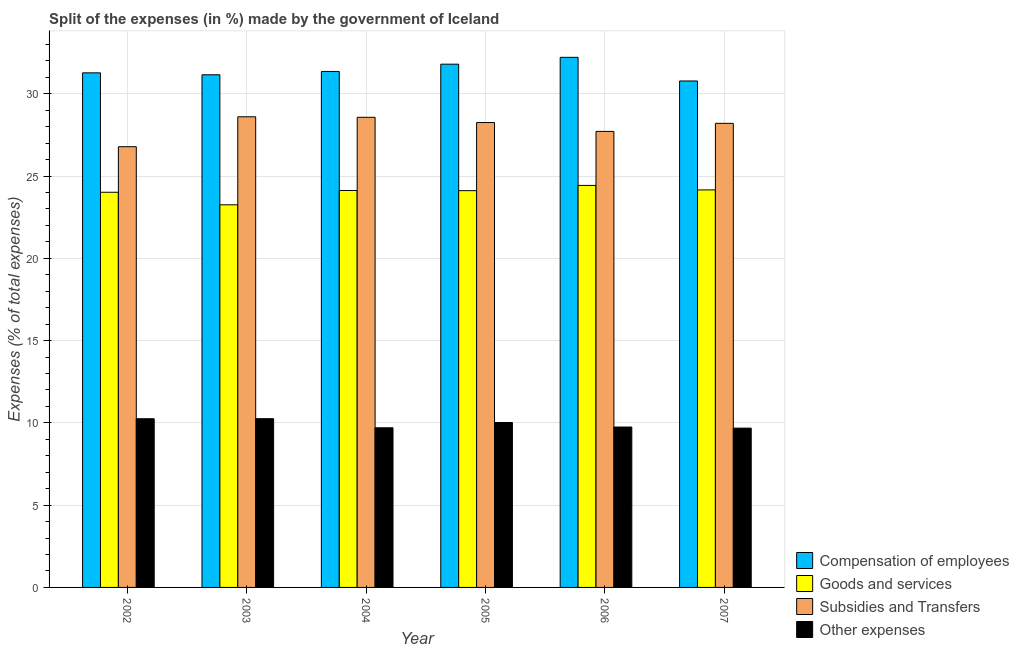How many different coloured bars are there?
Keep it short and to the point. 4. How many groups of bars are there?
Keep it short and to the point. 6. What is the label of the 3rd group of bars from the left?
Give a very brief answer. 2004. In how many cases, is the number of bars for a given year not equal to the number of legend labels?
Offer a very short reply. 0. What is the percentage of amount spent on goods and services in 2002?
Provide a short and direct response. 24.01. Across all years, what is the maximum percentage of amount spent on subsidies?
Your answer should be compact. 28.6. Across all years, what is the minimum percentage of amount spent on goods and services?
Give a very brief answer. 23.25. In which year was the percentage of amount spent on compensation of employees minimum?
Your response must be concise. 2007. What is the total percentage of amount spent on other expenses in the graph?
Provide a short and direct response. 59.66. What is the difference between the percentage of amount spent on subsidies in 2002 and that in 2004?
Provide a succinct answer. -1.79. What is the difference between the percentage of amount spent on goods and services in 2005 and the percentage of amount spent on other expenses in 2007?
Provide a short and direct response. -0.04. What is the average percentage of amount spent on compensation of employees per year?
Give a very brief answer. 31.43. In how many years, is the percentage of amount spent on other expenses greater than 32 %?
Provide a short and direct response. 0. What is the ratio of the percentage of amount spent on compensation of employees in 2004 to that in 2007?
Your answer should be compact. 1.02. Is the percentage of amount spent on compensation of employees in 2004 less than that in 2005?
Offer a terse response. Yes. Is the difference between the percentage of amount spent on other expenses in 2002 and 2004 greater than the difference between the percentage of amount spent on goods and services in 2002 and 2004?
Your answer should be very brief. No. What is the difference between the highest and the second highest percentage of amount spent on other expenses?
Your answer should be compact. 0. What is the difference between the highest and the lowest percentage of amount spent on other expenses?
Offer a terse response. 0.57. In how many years, is the percentage of amount spent on goods and services greater than the average percentage of amount spent on goods and services taken over all years?
Your response must be concise. 5. Is it the case that in every year, the sum of the percentage of amount spent on goods and services and percentage of amount spent on compensation of employees is greater than the sum of percentage of amount spent on other expenses and percentage of amount spent on subsidies?
Keep it short and to the point. Yes. What does the 3rd bar from the left in 2006 represents?
Provide a succinct answer. Subsidies and Transfers. What does the 2nd bar from the right in 2007 represents?
Make the answer very short. Subsidies and Transfers. Is it the case that in every year, the sum of the percentage of amount spent on compensation of employees and percentage of amount spent on goods and services is greater than the percentage of amount spent on subsidies?
Give a very brief answer. Yes. Are all the bars in the graph horizontal?
Offer a terse response. No. What is the difference between two consecutive major ticks on the Y-axis?
Your response must be concise. 5. Does the graph contain any zero values?
Provide a succinct answer. No. Does the graph contain grids?
Make the answer very short. Yes. Where does the legend appear in the graph?
Offer a terse response. Bottom right. How many legend labels are there?
Offer a terse response. 4. What is the title of the graph?
Offer a terse response. Split of the expenses (in %) made by the government of Iceland. What is the label or title of the Y-axis?
Offer a very short reply. Expenses (% of total expenses). What is the Expenses (% of total expenses) of Compensation of employees in 2002?
Your answer should be very brief. 31.27. What is the Expenses (% of total expenses) in Goods and services in 2002?
Make the answer very short. 24.01. What is the Expenses (% of total expenses) of Subsidies and Transfers in 2002?
Offer a terse response. 26.78. What is the Expenses (% of total expenses) of Other expenses in 2002?
Make the answer very short. 10.25. What is the Expenses (% of total expenses) in Compensation of employees in 2003?
Your answer should be compact. 31.15. What is the Expenses (% of total expenses) of Goods and services in 2003?
Provide a short and direct response. 23.25. What is the Expenses (% of total expenses) of Subsidies and Transfers in 2003?
Your answer should be very brief. 28.6. What is the Expenses (% of total expenses) in Other expenses in 2003?
Ensure brevity in your answer.  10.26. What is the Expenses (% of total expenses) in Compensation of employees in 2004?
Keep it short and to the point. 31.36. What is the Expenses (% of total expenses) of Goods and services in 2004?
Offer a very short reply. 24.12. What is the Expenses (% of total expenses) of Subsidies and Transfers in 2004?
Provide a short and direct response. 28.57. What is the Expenses (% of total expenses) of Other expenses in 2004?
Provide a succinct answer. 9.7. What is the Expenses (% of total expenses) in Compensation of employees in 2005?
Offer a terse response. 31.8. What is the Expenses (% of total expenses) of Goods and services in 2005?
Keep it short and to the point. 24.11. What is the Expenses (% of total expenses) in Subsidies and Transfers in 2005?
Your answer should be compact. 28.25. What is the Expenses (% of total expenses) in Other expenses in 2005?
Ensure brevity in your answer.  10.02. What is the Expenses (% of total expenses) of Compensation of employees in 2006?
Make the answer very short. 32.21. What is the Expenses (% of total expenses) of Goods and services in 2006?
Provide a short and direct response. 24.43. What is the Expenses (% of total expenses) of Subsidies and Transfers in 2006?
Your response must be concise. 27.71. What is the Expenses (% of total expenses) of Other expenses in 2006?
Make the answer very short. 9.75. What is the Expenses (% of total expenses) of Compensation of employees in 2007?
Keep it short and to the point. 30.78. What is the Expenses (% of total expenses) in Goods and services in 2007?
Make the answer very short. 24.16. What is the Expenses (% of total expenses) in Subsidies and Transfers in 2007?
Your answer should be compact. 28.2. What is the Expenses (% of total expenses) in Other expenses in 2007?
Provide a short and direct response. 9.68. Across all years, what is the maximum Expenses (% of total expenses) of Compensation of employees?
Offer a very short reply. 32.21. Across all years, what is the maximum Expenses (% of total expenses) of Goods and services?
Your response must be concise. 24.43. Across all years, what is the maximum Expenses (% of total expenses) of Subsidies and Transfers?
Offer a very short reply. 28.6. Across all years, what is the maximum Expenses (% of total expenses) of Other expenses?
Provide a succinct answer. 10.26. Across all years, what is the minimum Expenses (% of total expenses) in Compensation of employees?
Your response must be concise. 30.78. Across all years, what is the minimum Expenses (% of total expenses) in Goods and services?
Offer a very short reply. 23.25. Across all years, what is the minimum Expenses (% of total expenses) of Subsidies and Transfers?
Provide a succinct answer. 26.78. Across all years, what is the minimum Expenses (% of total expenses) of Other expenses?
Ensure brevity in your answer.  9.68. What is the total Expenses (% of total expenses) in Compensation of employees in the graph?
Give a very brief answer. 188.57. What is the total Expenses (% of total expenses) in Goods and services in the graph?
Keep it short and to the point. 144.09. What is the total Expenses (% of total expenses) of Subsidies and Transfers in the graph?
Make the answer very short. 168.12. What is the total Expenses (% of total expenses) of Other expenses in the graph?
Your answer should be compact. 59.66. What is the difference between the Expenses (% of total expenses) in Compensation of employees in 2002 and that in 2003?
Provide a succinct answer. 0.12. What is the difference between the Expenses (% of total expenses) of Goods and services in 2002 and that in 2003?
Keep it short and to the point. 0.76. What is the difference between the Expenses (% of total expenses) in Subsidies and Transfers in 2002 and that in 2003?
Provide a succinct answer. -1.82. What is the difference between the Expenses (% of total expenses) of Other expenses in 2002 and that in 2003?
Ensure brevity in your answer.  -0. What is the difference between the Expenses (% of total expenses) of Compensation of employees in 2002 and that in 2004?
Give a very brief answer. -0.09. What is the difference between the Expenses (% of total expenses) in Goods and services in 2002 and that in 2004?
Provide a short and direct response. -0.11. What is the difference between the Expenses (% of total expenses) in Subsidies and Transfers in 2002 and that in 2004?
Give a very brief answer. -1.79. What is the difference between the Expenses (% of total expenses) in Other expenses in 2002 and that in 2004?
Keep it short and to the point. 0.55. What is the difference between the Expenses (% of total expenses) in Compensation of employees in 2002 and that in 2005?
Your answer should be compact. -0.53. What is the difference between the Expenses (% of total expenses) of Goods and services in 2002 and that in 2005?
Keep it short and to the point. -0.1. What is the difference between the Expenses (% of total expenses) in Subsidies and Transfers in 2002 and that in 2005?
Make the answer very short. -1.47. What is the difference between the Expenses (% of total expenses) of Other expenses in 2002 and that in 2005?
Offer a very short reply. 0.23. What is the difference between the Expenses (% of total expenses) in Compensation of employees in 2002 and that in 2006?
Provide a short and direct response. -0.94. What is the difference between the Expenses (% of total expenses) in Goods and services in 2002 and that in 2006?
Keep it short and to the point. -0.42. What is the difference between the Expenses (% of total expenses) of Subsidies and Transfers in 2002 and that in 2006?
Keep it short and to the point. -0.93. What is the difference between the Expenses (% of total expenses) in Other expenses in 2002 and that in 2006?
Keep it short and to the point. 0.5. What is the difference between the Expenses (% of total expenses) in Compensation of employees in 2002 and that in 2007?
Make the answer very short. 0.49. What is the difference between the Expenses (% of total expenses) in Goods and services in 2002 and that in 2007?
Provide a succinct answer. -0.14. What is the difference between the Expenses (% of total expenses) in Subsidies and Transfers in 2002 and that in 2007?
Ensure brevity in your answer.  -1.42. What is the difference between the Expenses (% of total expenses) in Other expenses in 2002 and that in 2007?
Offer a terse response. 0.57. What is the difference between the Expenses (% of total expenses) in Compensation of employees in 2003 and that in 2004?
Your answer should be compact. -0.2. What is the difference between the Expenses (% of total expenses) in Goods and services in 2003 and that in 2004?
Provide a short and direct response. -0.87. What is the difference between the Expenses (% of total expenses) in Subsidies and Transfers in 2003 and that in 2004?
Make the answer very short. 0.03. What is the difference between the Expenses (% of total expenses) in Other expenses in 2003 and that in 2004?
Keep it short and to the point. 0.55. What is the difference between the Expenses (% of total expenses) in Compensation of employees in 2003 and that in 2005?
Keep it short and to the point. -0.65. What is the difference between the Expenses (% of total expenses) in Goods and services in 2003 and that in 2005?
Your answer should be very brief. -0.86. What is the difference between the Expenses (% of total expenses) in Subsidies and Transfers in 2003 and that in 2005?
Your answer should be very brief. 0.35. What is the difference between the Expenses (% of total expenses) in Other expenses in 2003 and that in 2005?
Give a very brief answer. 0.23. What is the difference between the Expenses (% of total expenses) of Compensation of employees in 2003 and that in 2006?
Keep it short and to the point. -1.06. What is the difference between the Expenses (% of total expenses) of Goods and services in 2003 and that in 2006?
Keep it short and to the point. -1.18. What is the difference between the Expenses (% of total expenses) of Subsidies and Transfers in 2003 and that in 2006?
Ensure brevity in your answer.  0.89. What is the difference between the Expenses (% of total expenses) in Other expenses in 2003 and that in 2006?
Keep it short and to the point. 0.51. What is the difference between the Expenses (% of total expenses) in Compensation of employees in 2003 and that in 2007?
Offer a very short reply. 0.38. What is the difference between the Expenses (% of total expenses) of Goods and services in 2003 and that in 2007?
Your answer should be very brief. -0.91. What is the difference between the Expenses (% of total expenses) of Subsidies and Transfers in 2003 and that in 2007?
Your answer should be very brief. 0.4. What is the difference between the Expenses (% of total expenses) in Other expenses in 2003 and that in 2007?
Offer a very short reply. 0.57. What is the difference between the Expenses (% of total expenses) in Compensation of employees in 2004 and that in 2005?
Your response must be concise. -0.44. What is the difference between the Expenses (% of total expenses) of Goods and services in 2004 and that in 2005?
Ensure brevity in your answer.  0.01. What is the difference between the Expenses (% of total expenses) in Subsidies and Transfers in 2004 and that in 2005?
Provide a succinct answer. 0.32. What is the difference between the Expenses (% of total expenses) in Other expenses in 2004 and that in 2005?
Offer a very short reply. -0.32. What is the difference between the Expenses (% of total expenses) in Compensation of employees in 2004 and that in 2006?
Offer a very short reply. -0.86. What is the difference between the Expenses (% of total expenses) of Goods and services in 2004 and that in 2006?
Offer a terse response. -0.31. What is the difference between the Expenses (% of total expenses) in Subsidies and Transfers in 2004 and that in 2006?
Make the answer very short. 0.86. What is the difference between the Expenses (% of total expenses) in Other expenses in 2004 and that in 2006?
Your answer should be very brief. -0.05. What is the difference between the Expenses (% of total expenses) of Compensation of employees in 2004 and that in 2007?
Your answer should be compact. 0.58. What is the difference between the Expenses (% of total expenses) of Goods and services in 2004 and that in 2007?
Your answer should be very brief. -0.03. What is the difference between the Expenses (% of total expenses) of Subsidies and Transfers in 2004 and that in 2007?
Your answer should be compact. 0.37. What is the difference between the Expenses (% of total expenses) of Other expenses in 2004 and that in 2007?
Your answer should be compact. 0.02. What is the difference between the Expenses (% of total expenses) in Compensation of employees in 2005 and that in 2006?
Keep it short and to the point. -0.42. What is the difference between the Expenses (% of total expenses) of Goods and services in 2005 and that in 2006?
Your response must be concise. -0.32. What is the difference between the Expenses (% of total expenses) of Subsidies and Transfers in 2005 and that in 2006?
Your response must be concise. 0.54. What is the difference between the Expenses (% of total expenses) in Other expenses in 2005 and that in 2006?
Keep it short and to the point. 0.28. What is the difference between the Expenses (% of total expenses) of Compensation of employees in 2005 and that in 2007?
Your answer should be very brief. 1.02. What is the difference between the Expenses (% of total expenses) of Goods and services in 2005 and that in 2007?
Ensure brevity in your answer.  -0.04. What is the difference between the Expenses (% of total expenses) in Subsidies and Transfers in 2005 and that in 2007?
Make the answer very short. 0.05. What is the difference between the Expenses (% of total expenses) of Other expenses in 2005 and that in 2007?
Make the answer very short. 0.34. What is the difference between the Expenses (% of total expenses) in Compensation of employees in 2006 and that in 2007?
Your response must be concise. 1.44. What is the difference between the Expenses (% of total expenses) of Goods and services in 2006 and that in 2007?
Provide a short and direct response. 0.27. What is the difference between the Expenses (% of total expenses) in Subsidies and Transfers in 2006 and that in 2007?
Your answer should be very brief. -0.49. What is the difference between the Expenses (% of total expenses) of Other expenses in 2006 and that in 2007?
Keep it short and to the point. 0.07. What is the difference between the Expenses (% of total expenses) in Compensation of employees in 2002 and the Expenses (% of total expenses) in Goods and services in 2003?
Provide a short and direct response. 8.02. What is the difference between the Expenses (% of total expenses) in Compensation of employees in 2002 and the Expenses (% of total expenses) in Subsidies and Transfers in 2003?
Give a very brief answer. 2.67. What is the difference between the Expenses (% of total expenses) of Compensation of employees in 2002 and the Expenses (% of total expenses) of Other expenses in 2003?
Ensure brevity in your answer.  21.02. What is the difference between the Expenses (% of total expenses) of Goods and services in 2002 and the Expenses (% of total expenses) of Subsidies and Transfers in 2003?
Ensure brevity in your answer.  -4.59. What is the difference between the Expenses (% of total expenses) in Goods and services in 2002 and the Expenses (% of total expenses) in Other expenses in 2003?
Provide a short and direct response. 13.76. What is the difference between the Expenses (% of total expenses) in Subsidies and Transfers in 2002 and the Expenses (% of total expenses) in Other expenses in 2003?
Provide a succinct answer. 16.53. What is the difference between the Expenses (% of total expenses) in Compensation of employees in 2002 and the Expenses (% of total expenses) in Goods and services in 2004?
Give a very brief answer. 7.15. What is the difference between the Expenses (% of total expenses) of Compensation of employees in 2002 and the Expenses (% of total expenses) of Subsidies and Transfers in 2004?
Your answer should be very brief. 2.7. What is the difference between the Expenses (% of total expenses) in Compensation of employees in 2002 and the Expenses (% of total expenses) in Other expenses in 2004?
Offer a very short reply. 21.57. What is the difference between the Expenses (% of total expenses) in Goods and services in 2002 and the Expenses (% of total expenses) in Subsidies and Transfers in 2004?
Give a very brief answer. -4.55. What is the difference between the Expenses (% of total expenses) in Goods and services in 2002 and the Expenses (% of total expenses) in Other expenses in 2004?
Make the answer very short. 14.31. What is the difference between the Expenses (% of total expenses) of Subsidies and Transfers in 2002 and the Expenses (% of total expenses) of Other expenses in 2004?
Keep it short and to the point. 17.08. What is the difference between the Expenses (% of total expenses) in Compensation of employees in 2002 and the Expenses (% of total expenses) in Goods and services in 2005?
Your answer should be very brief. 7.16. What is the difference between the Expenses (% of total expenses) in Compensation of employees in 2002 and the Expenses (% of total expenses) in Subsidies and Transfers in 2005?
Give a very brief answer. 3.02. What is the difference between the Expenses (% of total expenses) of Compensation of employees in 2002 and the Expenses (% of total expenses) of Other expenses in 2005?
Provide a short and direct response. 21.25. What is the difference between the Expenses (% of total expenses) in Goods and services in 2002 and the Expenses (% of total expenses) in Subsidies and Transfers in 2005?
Offer a terse response. -4.24. What is the difference between the Expenses (% of total expenses) in Goods and services in 2002 and the Expenses (% of total expenses) in Other expenses in 2005?
Your answer should be compact. 13.99. What is the difference between the Expenses (% of total expenses) of Subsidies and Transfers in 2002 and the Expenses (% of total expenses) of Other expenses in 2005?
Offer a very short reply. 16.76. What is the difference between the Expenses (% of total expenses) of Compensation of employees in 2002 and the Expenses (% of total expenses) of Goods and services in 2006?
Provide a succinct answer. 6.84. What is the difference between the Expenses (% of total expenses) in Compensation of employees in 2002 and the Expenses (% of total expenses) in Subsidies and Transfers in 2006?
Give a very brief answer. 3.56. What is the difference between the Expenses (% of total expenses) of Compensation of employees in 2002 and the Expenses (% of total expenses) of Other expenses in 2006?
Your answer should be very brief. 21.52. What is the difference between the Expenses (% of total expenses) in Goods and services in 2002 and the Expenses (% of total expenses) in Subsidies and Transfers in 2006?
Offer a terse response. -3.7. What is the difference between the Expenses (% of total expenses) in Goods and services in 2002 and the Expenses (% of total expenses) in Other expenses in 2006?
Your answer should be very brief. 14.27. What is the difference between the Expenses (% of total expenses) in Subsidies and Transfers in 2002 and the Expenses (% of total expenses) in Other expenses in 2006?
Offer a terse response. 17.04. What is the difference between the Expenses (% of total expenses) in Compensation of employees in 2002 and the Expenses (% of total expenses) in Goods and services in 2007?
Make the answer very short. 7.11. What is the difference between the Expenses (% of total expenses) of Compensation of employees in 2002 and the Expenses (% of total expenses) of Subsidies and Transfers in 2007?
Ensure brevity in your answer.  3.07. What is the difference between the Expenses (% of total expenses) of Compensation of employees in 2002 and the Expenses (% of total expenses) of Other expenses in 2007?
Your response must be concise. 21.59. What is the difference between the Expenses (% of total expenses) of Goods and services in 2002 and the Expenses (% of total expenses) of Subsidies and Transfers in 2007?
Provide a succinct answer. -4.19. What is the difference between the Expenses (% of total expenses) in Goods and services in 2002 and the Expenses (% of total expenses) in Other expenses in 2007?
Your response must be concise. 14.33. What is the difference between the Expenses (% of total expenses) in Subsidies and Transfers in 2002 and the Expenses (% of total expenses) in Other expenses in 2007?
Make the answer very short. 17.1. What is the difference between the Expenses (% of total expenses) in Compensation of employees in 2003 and the Expenses (% of total expenses) in Goods and services in 2004?
Your response must be concise. 7.03. What is the difference between the Expenses (% of total expenses) of Compensation of employees in 2003 and the Expenses (% of total expenses) of Subsidies and Transfers in 2004?
Provide a short and direct response. 2.58. What is the difference between the Expenses (% of total expenses) of Compensation of employees in 2003 and the Expenses (% of total expenses) of Other expenses in 2004?
Make the answer very short. 21.45. What is the difference between the Expenses (% of total expenses) in Goods and services in 2003 and the Expenses (% of total expenses) in Subsidies and Transfers in 2004?
Ensure brevity in your answer.  -5.32. What is the difference between the Expenses (% of total expenses) in Goods and services in 2003 and the Expenses (% of total expenses) in Other expenses in 2004?
Keep it short and to the point. 13.55. What is the difference between the Expenses (% of total expenses) in Subsidies and Transfers in 2003 and the Expenses (% of total expenses) in Other expenses in 2004?
Your answer should be compact. 18.9. What is the difference between the Expenses (% of total expenses) of Compensation of employees in 2003 and the Expenses (% of total expenses) of Goods and services in 2005?
Offer a very short reply. 7.04. What is the difference between the Expenses (% of total expenses) in Compensation of employees in 2003 and the Expenses (% of total expenses) in Subsidies and Transfers in 2005?
Make the answer very short. 2.9. What is the difference between the Expenses (% of total expenses) in Compensation of employees in 2003 and the Expenses (% of total expenses) in Other expenses in 2005?
Make the answer very short. 21.13. What is the difference between the Expenses (% of total expenses) in Goods and services in 2003 and the Expenses (% of total expenses) in Subsidies and Transfers in 2005?
Offer a terse response. -5. What is the difference between the Expenses (% of total expenses) of Goods and services in 2003 and the Expenses (% of total expenses) of Other expenses in 2005?
Give a very brief answer. 13.23. What is the difference between the Expenses (% of total expenses) of Subsidies and Transfers in 2003 and the Expenses (% of total expenses) of Other expenses in 2005?
Offer a terse response. 18.58. What is the difference between the Expenses (% of total expenses) of Compensation of employees in 2003 and the Expenses (% of total expenses) of Goods and services in 2006?
Your answer should be compact. 6.72. What is the difference between the Expenses (% of total expenses) in Compensation of employees in 2003 and the Expenses (% of total expenses) in Subsidies and Transfers in 2006?
Your answer should be very brief. 3.44. What is the difference between the Expenses (% of total expenses) of Compensation of employees in 2003 and the Expenses (% of total expenses) of Other expenses in 2006?
Your answer should be compact. 21.41. What is the difference between the Expenses (% of total expenses) of Goods and services in 2003 and the Expenses (% of total expenses) of Subsidies and Transfers in 2006?
Offer a terse response. -4.46. What is the difference between the Expenses (% of total expenses) in Goods and services in 2003 and the Expenses (% of total expenses) in Other expenses in 2006?
Your answer should be very brief. 13.5. What is the difference between the Expenses (% of total expenses) of Subsidies and Transfers in 2003 and the Expenses (% of total expenses) of Other expenses in 2006?
Your response must be concise. 18.85. What is the difference between the Expenses (% of total expenses) of Compensation of employees in 2003 and the Expenses (% of total expenses) of Goods and services in 2007?
Make the answer very short. 7. What is the difference between the Expenses (% of total expenses) in Compensation of employees in 2003 and the Expenses (% of total expenses) in Subsidies and Transfers in 2007?
Your answer should be very brief. 2.95. What is the difference between the Expenses (% of total expenses) in Compensation of employees in 2003 and the Expenses (% of total expenses) in Other expenses in 2007?
Keep it short and to the point. 21.47. What is the difference between the Expenses (% of total expenses) in Goods and services in 2003 and the Expenses (% of total expenses) in Subsidies and Transfers in 2007?
Your answer should be compact. -4.95. What is the difference between the Expenses (% of total expenses) of Goods and services in 2003 and the Expenses (% of total expenses) of Other expenses in 2007?
Offer a very short reply. 13.57. What is the difference between the Expenses (% of total expenses) in Subsidies and Transfers in 2003 and the Expenses (% of total expenses) in Other expenses in 2007?
Offer a very short reply. 18.92. What is the difference between the Expenses (% of total expenses) in Compensation of employees in 2004 and the Expenses (% of total expenses) in Goods and services in 2005?
Provide a succinct answer. 7.24. What is the difference between the Expenses (% of total expenses) in Compensation of employees in 2004 and the Expenses (% of total expenses) in Subsidies and Transfers in 2005?
Give a very brief answer. 3.11. What is the difference between the Expenses (% of total expenses) of Compensation of employees in 2004 and the Expenses (% of total expenses) of Other expenses in 2005?
Keep it short and to the point. 21.33. What is the difference between the Expenses (% of total expenses) in Goods and services in 2004 and the Expenses (% of total expenses) in Subsidies and Transfers in 2005?
Your response must be concise. -4.13. What is the difference between the Expenses (% of total expenses) in Goods and services in 2004 and the Expenses (% of total expenses) in Other expenses in 2005?
Give a very brief answer. 14.1. What is the difference between the Expenses (% of total expenses) in Subsidies and Transfers in 2004 and the Expenses (% of total expenses) in Other expenses in 2005?
Your answer should be very brief. 18.55. What is the difference between the Expenses (% of total expenses) in Compensation of employees in 2004 and the Expenses (% of total expenses) in Goods and services in 2006?
Provide a short and direct response. 6.93. What is the difference between the Expenses (% of total expenses) of Compensation of employees in 2004 and the Expenses (% of total expenses) of Subsidies and Transfers in 2006?
Your response must be concise. 3.64. What is the difference between the Expenses (% of total expenses) in Compensation of employees in 2004 and the Expenses (% of total expenses) in Other expenses in 2006?
Your answer should be compact. 21.61. What is the difference between the Expenses (% of total expenses) of Goods and services in 2004 and the Expenses (% of total expenses) of Subsidies and Transfers in 2006?
Offer a terse response. -3.59. What is the difference between the Expenses (% of total expenses) in Goods and services in 2004 and the Expenses (% of total expenses) in Other expenses in 2006?
Give a very brief answer. 14.38. What is the difference between the Expenses (% of total expenses) of Subsidies and Transfers in 2004 and the Expenses (% of total expenses) of Other expenses in 2006?
Your response must be concise. 18.82. What is the difference between the Expenses (% of total expenses) in Compensation of employees in 2004 and the Expenses (% of total expenses) in Goods and services in 2007?
Make the answer very short. 7.2. What is the difference between the Expenses (% of total expenses) of Compensation of employees in 2004 and the Expenses (% of total expenses) of Subsidies and Transfers in 2007?
Keep it short and to the point. 3.15. What is the difference between the Expenses (% of total expenses) in Compensation of employees in 2004 and the Expenses (% of total expenses) in Other expenses in 2007?
Keep it short and to the point. 21.68. What is the difference between the Expenses (% of total expenses) in Goods and services in 2004 and the Expenses (% of total expenses) in Subsidies and Transfers in 2007?
Keep it short and to the point. -4.08. What is the difference between the Expenses (% of total expenses) of Goods and services in 2004 and the Expenses (% of total expenses) of Other expenses in 2007?
Your answer should be very brief. 14.44. What is the difference between the Expenses (% of total expenses) in Subsidies and Transfers in 2004 and the Expenses (% of total expenses) in Other expenses in 2007?
Your answer should be compact. 18.89. What is the difference between the Expenses (% of total expenses) in Compensation of employees in 2005 and the Expenses (% of total expenses) in Goods and services in 2006?
Keep it short and to the point. 7.37. What is the difference between the Expenses (% of total expenses) of Compensation of employees in 2005 and the Expenses (% of total expenses) of Subsidies and Transfers in 2006?
Provide a succinct answer. 4.08. What is the difference between the Expenses (% of total expenses) in Compensation of employees in 2005 and the Expenses (% of total expenses) in Other expenses in 2006?
Offer a very short reply. 22.05. What is the difference between the Expenses (% of total expenses) in Goods and services in 2005 and the Expenses (% of total expenses) in Subsidies and Transfers in 2006?
Ensure brevity in your answer.  -3.6. What is the difference between the Expenses (% of total expenses) of Goods and services in 2005 and the Expenses (% of total expenses) of Other expenses in 2006?
Keep it short and to the point. 14.36. What is the difference between the Expenses (% of total expenses) in Subsidies and Transfers in 2005 and the Expenses (% of total expenses) in Other expenses in 2006?
Keep it short and to the point. 18.5. What is the difference between the Expenses (% of total expenses) in Compensation of employees in 2005 and the Expenses (% of total expenses) in Goods and services in 2007?
Your answer should be very brief. 7.64. What is the difference between the Expenses (% of total expenses) in Compensation of employees in 2005 and the Expenses (% of total expenses) in Subsidies and Transfers in 2007?
Your answer should be compact. 3.6. What is the difference between the Expenses (% of total expenses) in Compensation of employees in 2005 and the Expenses (% of total expenses) in Other expenses in 2007?
Keep it short and to the point. 22.12. What is the difference between the Expenses (% of total expenses) in Goods and services in 2005 and the Expenses (% of total expenses) in Subsidies and Transfers in 2007?
Provide a short and direct response. -4.09. What is the difference between the Expenses (% of total expenses) in Goods and services in 2005 and the Expenses (% of total expenses) in Other expenses in 2007?
Provide a short and direct response. 14.43. What is the difference between the Expenses (% of total expenses) in Subsidies and Transfers in 2005 and the Expenses (% of total expenses) in Other expenses in 2007?
Your response must be concise. 18.57. What is the difference between the Expenses (% of total expenses) in Compensation of employees in 2006 and the Expenses (% of total expenses) in Goods and services in 2007?
Your response must be concise. 8.06. What is the difference between the Expenses (% of total expenses) in Compensation of employees in 2006 and the Expenses (% of total expenses) in Subsidies and Transfers in 2007?
Keep it short and to the point. 4.01. What is the difference between the Expenses (% of total expenses) of Compensation of employees in 2006 and the Expenses (% of total expenses) of Other expenses in 2007?
Make the answer very short. 22.53. What is the difference between the Expenses (% of total expenses) in Goods and services in 2006 and the Expenses (% of total expenses) in Subsidies and Transfers in 2007?
Make the answer very short. -3.77. What is the difference between the Expenses (% of total expenses) of Goods and services in 2006 and the Expenses (% of total expenses) of Other expenses in 2007?
Provide a succinct answer. 14.75. What is the difference between the Expenses (% of total expenses) in Subsidies and Transfers in 2006 and the Expenses (% of total expenses) in Other expenses in 2007?
Ensure brevity in your answer.  18.03. What is the average Expenses (% of total expenses) in Compensation of employees per year?
Offer a very short reply. 31.43. What is the average Expenses (% of total expenses) in Goods and services per year?
Make the answer very short. 24.01. What is the average Expenses (% of total expenses) of Subsidies and Transfers per year?
Offer a terse response. 28.02. What is the average Expenses (% of total expenses) in Other expenses per year?
Ensure brevity in your answer.  9.94. In the year 2002, what is the difference between the Expenses (% of total expenses) of Compensation of employees and Expenses (% of total expenses) of Goods and services?
Offer a very short reply. 7.26. In the year 2002, what is the difference between the Expenses (% of total expenses) of Compensation of employees and Expenses (% of total expenses) of Subsidies and Transfers?
Offer a terse response. 4.49. In the year 2002, what is the difference between the Expenses (% of total expenses) of Compensation of employees and Expenses (% of total expenses) of Other expenses?
Your answer should be very brief. 21.02. In the year 2002, what is the difference between the Expenses (% of total expenses) in Goods and services and Expenses (% of total expenses) in Subsidies and Transfers?
Make the answer very short. -2.77. In the year 2002, what is the difference between the Expenses (% of total expenses) in Goods and services and Expenses (% of total expenses) in Other expenses?
Your answer should be very brief. 13.76. In the year 2002, what is the difference between the Expenses (% of total expenses) of Subsidies and Transfers and Expenses (% of total expenses) of Other expenses?
Provide a succinct answer. 16.53. In the year 2003, what is the difference between the Expenses (% of total expenses) in Compensation of employees and Expenses (% of total expenses) in Goods and services?
Offer a very short reply. 7.9. In the year 2003, what is the difference between the Expenses (% of total expenses) of Compensation of employees and Expenses (% of total expenses) of Subsidies and Transfers?
Offer a very short reply. 2.55. In the year 2003, what is the difference between the Expenses (% of total expenses) of Compensation of employees and Expenses (% of total expenses) of Other expenses?
Your answer should be very brief. 20.9. In the year 2003, what is the difference between the Expenses (% of total expenses) of Goods and services and Expenses (% of total expenses) of Subsidies and Transfers?
Your response must be concise. -5.35. In the year 2003, what is the difference between the Expenses (% of total expenses) of Goods and services and Expenses (% of total expenses) of Other expenses?
Give a very brief answer. 13. In the year 2003, what is the difference between the Expenses (% of total expenses) in Subsidies and Transfers and Expenses (% of total expenses) in Other expenses?
Offer a terse response. 18.35. In the year 2004, what is the difference between the Expenses (% of total expenses) in Compensation of employees and Expenses (% of total expenses) in Goods and services?
Make the answer very short. 7.23. In the year 2004, what is the difference between the Expenses (% of total expenses) of Compensation of employees and Expenses (% of total expenses) of Subsidies and Transfers?
Give a very brief answer. 2.79. In the year 2004, what is the difference between the Expenses (% of total expenses) of Compensation of employees and Expenses (% of total expenses) of Other expenses?
Your response must be concise. 21.66. In the year 2004, what is the difference between the Expenses (% of total expenses) of Goods and services and Expenses (% of total expenses) of Subsidies and Transfers?
Give a very brief answer. -4.45. In the year 2004, what is the difference between the Expenses (% of total expenses) of Goods and services and Expenses (% of total expenses) of Other expenses?
Provide a short and direct response. 14.42. In the year 2004, what is the difference between the Expenses (% of total expenses) in Subsidies and Transfers and Expenses (% of total expenses) in Other expenses?
Provide a short and direct response. 18.87. In the year 2005, what is the difference between the Expenses (% of total expenses) of Compensation of employees and Expenses (% of total expenses) of Goods and services?
Keep it short and to the point. 7.69. In the year 2005, what is the difference between the Expenses (% of total expenses) of Compensation of employees and Expenses (% of total expenses) of Subsidies and Transfers?
Keep it short and to the point. 3.55. In the year 2005, what is the difference between the Expenses (% of total expenses) in Compensation of employees and Expenses (% of total expenses) in Other expenses?
Give a very brief answer. 21.78. In the year 2005, what is the difference between the Expenses (% of total expenses) in Goods and services and Expenses (% of total expenses) in Subsidies and Transfers?
Offer a terse response. -4.14. In the year 2005, what is the difference between the Expenses (% of total expenses) in Goods and services and Expenses (% of total expenses) in Other expenses?
Ensure brevity in your answer.  14.09. In the year 2005, what is the difference between the Expenses (% of total expenses) of Subsidies and Transfers and Expenses (% of total expenses) of Other expenses?
Your answer should be compact. 18.23. In the year 2006, what is the difference between the Expenses (% of total expenses) in Compensation of employees and Expenses (% of total expenses) in Goods and services?
Your answer should be compact. 7.78. In the year 2006, what is the difference between the Expenses (% of total expenses) in Compensation of employees and Expenses (% of total expenses) in Subsidies and Transfers?
Ensure brevity in your answer.  4.5. In the year 2006, what is the difference between the Expenses (% of total expenses) in Compensation of employees and Expenses (% of total expenses) in Other expenses?
Provide a succinct answer. 22.47. In the year 2006, what is the difference between the Expenses (% of total expenses) in Goods and services and Expenses (% of total expenses) in Subsidies and Transfers?
Your answer should be very brief. -3.28. In the year 2006, what is the difference between the Expenses (% of total expenses) in Goods and services and Expenses (% of total expenses) in Other expenses?
Make the answer very short. 14.68. In the year 2006, what is the difference between the Expenses (% of total expenses) of Subsidies and Transfers and Expenses (% of total expenses) of Other expenses?
Provide a succinct answer. 17.97. In the year 2007, what is the difference between the Expenses (% of total expenses) of Compensation of employees and Expenses (% of total expenses) of Goods and services?
Offer a very short reply. 6.62. In the year 2007, what is the difference between the Expenses (% of total expenses) of Compensation of employees and Expenses (% of total expenses) of Subsidies and Transfers?
Your answer should be compact. 2.57. In the year 2007, what is the difference between the Expenses (% of total expenses) of Compensation of employees and Expenses (% of total expenses) of Other expenses?
Ensure brevity in your answer.  21.1. In the year 2007, what is the difference between the Expenses (% of total expenses) of Goods and services and Expenses (% of total expenses) of Subsidies and Transfers?
Your answer should be very brief. -4.05. In the year 2007, what is the difference between the Expenses (% of total expenses) in Goods and services and Expenses (% of total expenses) in Other expenses?
Offer a terse response. 14.48. In the year 2007, what is the difference between the Expenses (% of total expenses) of Subsidies and Transfers and Expenses (% of total expenses) of Other expenses?
Ensure brevity in your answer.  18.52. What is the ratio of the Expenses (% of total expenses) of Goods and services in 2002 to that in 2003?
Provide a short and direct response. 1.03. What is the ratio of the Expenses (% of total expenses) of Subsidies and Transfers in 2002 to that in 2003?
Your answer should be very brief. 0.94. What is the ratio of the Expenses (% of total expenses) in Compensation of employees in 2002 to that in 2004?
Provide a short and direct response. 1. What is the ratio of the Expenses (% of total expenses) of Goods and services in 2002 to that in 2004?
Your response must be concise. 1. What is the ratio of the Expenses (% of total expenses) of Subsidies and Transfers in 2002 to that in 2004?
Keep it short and to the point. 0.94. What is the ratio of the Expenses (% of total expenses) in Other expenses in 2002 to that in 2004?
Provide a succinct answer. 1.06. What is the ratio of the Expenses (% of total expenses) in Compensation of employees in 2002 to that in 2005?
Your answer should be compact. 0.98. What is the ratio of the Expenses (% of total expenses) of Goods and services in 2002 to that in 2005?
Your response must be concise. 1. What is the ratio of the Expenses (% of total expenses) in Subsidies and Transfers in 2002 to that in 2005?
Your response must be concise. 0.95. What is the ratio of the Expenses (% of total expenses) in Other expenses in 2002 to that in 2005?
Ensure brevity in your answer.  1.02. What is the ratio of the Expenses (% of total expenses) of Compensation of employees in 2002 to that in 2006?
Offer a very short reply. 0.97. What is the ratio of the Expenses (% of total expenses) of Goods and services in 2002 to that in 2006?
Make the answer very short. 0.98. What is the ratio of the Expenses (% of total expenses) in Subsidies and Transfers in 2002 to that in 2006?
Your answer should be compact. 0.97. What is the ratio of the Expenses (% of total expenses) of Other expenses in 2002 to that in 2006?
Give a very brief answer. 1.05. What is the ratio of the Expenses (% of total expenses) of Subsidies and Transfers in 2002 to that in 2007?
Keep it short and to the point. 0.95. What is the ratio of the Expenses (% of total expenses) of Other expenses in 2002 to that in 2007?
Your answer should be very brief. 1.06. What is the ratio of the Expenses (% of total expenses) in Compensation of employees in 2003 to that in 2004?
Your response must be concise. 0.99. What is the ratio of the Expenses (% of total expenses) in Goods and services in 2003 to that in 2004?
Your answer should be compact. 0.96. What is the ratio of the Expenses (% of total expenses) of Other expenses in 2003 to that in 2004?
Offer a terse response. 1.06. What is the ratio of the Expenses (% of total expenses) in Compensation of employees in 2003 to that in 2005?
Offer a very short reply. 0.98. What is the ratio of the Expenses (% of total expenses) in Goods and services in 2003 to that in 2005?
Provide a short and direct response. 0.96. What is the ratio of the Expenses (% of total expenses) in Subsidies and Transfers in 2003 to that in 2005?
Your response must be concise. 1.01. What is the ratio of the Expenses (% of total expenses) in Other expenses in 2003 to that in 2005?
Make the answer very short. 1.02. What is the ratio of the Expenses (% of total expenses) of Compensation of employees in 2003 to that in 2006?
Provide a short and direct response. 0.97. What is the ratio of the Expenses (% of total expenses) in Goods and services in 2003 to that in 2006?
Give a very brief answer. 0.95. What is the ratio of the Expenses (% of total expenses) in Subsidies and Transfers in 2003 to that in 2006?
Your answer should be very brief. 1.03. What is the ratio of the Expenses (% of total expenses) in Other expenses in 2003 to that in 2006?
Your answer should be very brief. 1.05. What is the ratio of the Expenses (% of total expenses) of Compensation of employees in 2003 to that in 2007?
Make the answer very short. 1.01. What is the ratio of the Expenses (% of total expenses) in Goods and services in 2003 to that in 2007?
Your answer should be compact. 0.96. What is the ratio of the Expenses (% of total expenses) in Subsidies and Transfers in 2003 to that in 2007?
Make the answer very short. 1.01. What is the ratio of the Expenses (% of total expenses) in Other expenses in 2003 to that in 2007?
Provide a succinct answer. 1.06. What is the ratio of the Expenses (% of total expenses) in Compensation of employees in 2004 to that in 2005?
Make the answer very short. 0.99. What is the ratio of the Expenses (% of total expenses) of Goods and services in 2004 to that in 2005?
Your answer should be compact. 1. What is the ratio of the Expenses (% of total expenses) of Subsidies and Transfers in 2004 to that in 2005?
Provide a short and direct response. 1.01. What is the ratio of the Expenses (% of total expenses) of Compensation of employees in 2004 to that in 2006?
Offer a very short reply. 0.97. What is the ratio of the Expenses (% of total expenses) in Goods and services in 2004 to that in 2006?
Offer a terse response. 0.99. What is the ratio of the Expenses (% of total expenses) of Subsidies and Transfers in 2004 to that in 2006?
Your response must be concise. 1.03. What is the ratio of the Expenses (% of total expenses) of Other expenses in 2004 to that in 2006?
Provide a succinct answer. 1. What is the ratio of the Expenses (% of total expenses) in Compensation of employees in 2004 to that in 2007?
Give a very brief answer. 1.02. What is the ratio of the Expenses (% of total expenses) in Goods and services in 2004 to that in 2007?
Provide a succinct answer. 1. What is the ratio of the Expenses (% of total expenses) in Other expenses in 2004 to that in 2007?
Keep it short and to the point. 1. What is the ratio of the Expenses (% of total expenses) of Compensation of employees in 2005 to that in 2006?
Make the answer very short. 0.99. What is the ratio of the Expenses (% of total expenses) of Subsidies and Transfers in 2005 to that in 2006?
Keep it short and to the point. 1.02. What is the ratio of the Expenses (% of total expenses) in Other expenses in 2005 to that in 2006?
Provide a short and direct response. 1.03. What is the ratio of the Expenses (% of total expenses) in Compensation of employees in 2005 to that in 2007?
Provide a succinct answer. 1.03. What is the ratio of the Expenses (% of total expenses) of Goods and services in 2005 to that in 2007?
Give a very brief answer. 1. What is the ratio of the Expenses (% of total expenses) in Subsidies and Transfers in 2005 to that in 2007?
Provide a succinct answer. 1. What is the ratio of the Expenses (% of total expenses) in Other expenses in 2005 to that in 2007?
Your response must be concise. 1.04. What is the ratio of the Expenses (% of total expenses) in Compensation of employees in 2006 to that in 2007?
Keep it short and to the point. 1.05. What is the ratio of the Expenses (% of total expenses) of Goods and services in 2006 to that in 2007?
Provide a succinct answer. 1.01. What is the ratio of the Expenses (% of total expenses) in Subsidies and Transfers in 2006 to that in 2007?
Provide a short and direct response. 0.98. What is the difference between the highest and the second highest Expenses (% of total expenses) in Compensation of employees?
Provide a short and direct response. 0.42. What is the difference between the highest and the second highest Expenses (% of total expenses) of Goods and services?
Ensure brevity in your answer.  0.27. What is the difference between the highest and the second highest Expenses (% of total expenses) of Subsidies and Transfers?
Your answer should be very brief. 0.03. What is the difference between the highest and the second highest Expenses (% of total expenses) of Other expenses?
Offer a terse response. 0. What is the difference between the highest and the lowest Expenses (% of total expenses) of Compensation of employees?
Provide a short and direct response. 1.44. What is the difference between the highest and the lowest Expenses (% of total expenses) of Goods and services?
Offer a very short reply. 1.18. What is the difference between the highest and the lowest Expenses (% of total expenses) in Subsidies and Transfers?
Offer a terse response. 1.82. What is the difference between the highest and the lowest Expenses (% of total expenses) of Other expenses?
Your response must be concise. 0.57. 